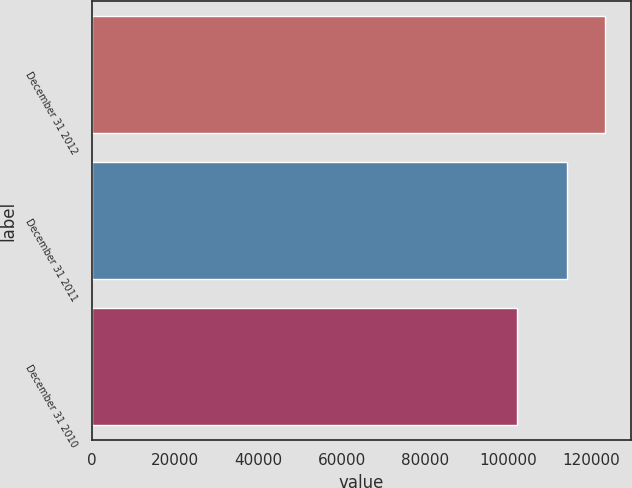Convert chart to OTSL. <chart><loc_0><loc_0><loc_500><loc_500><bar_chart><fcel>December 31 2012<fcel>December 31 2011<fcel>December 31 2010<nl><fcel>123438<fcel>114198<fcel>102200<nl></chart> 